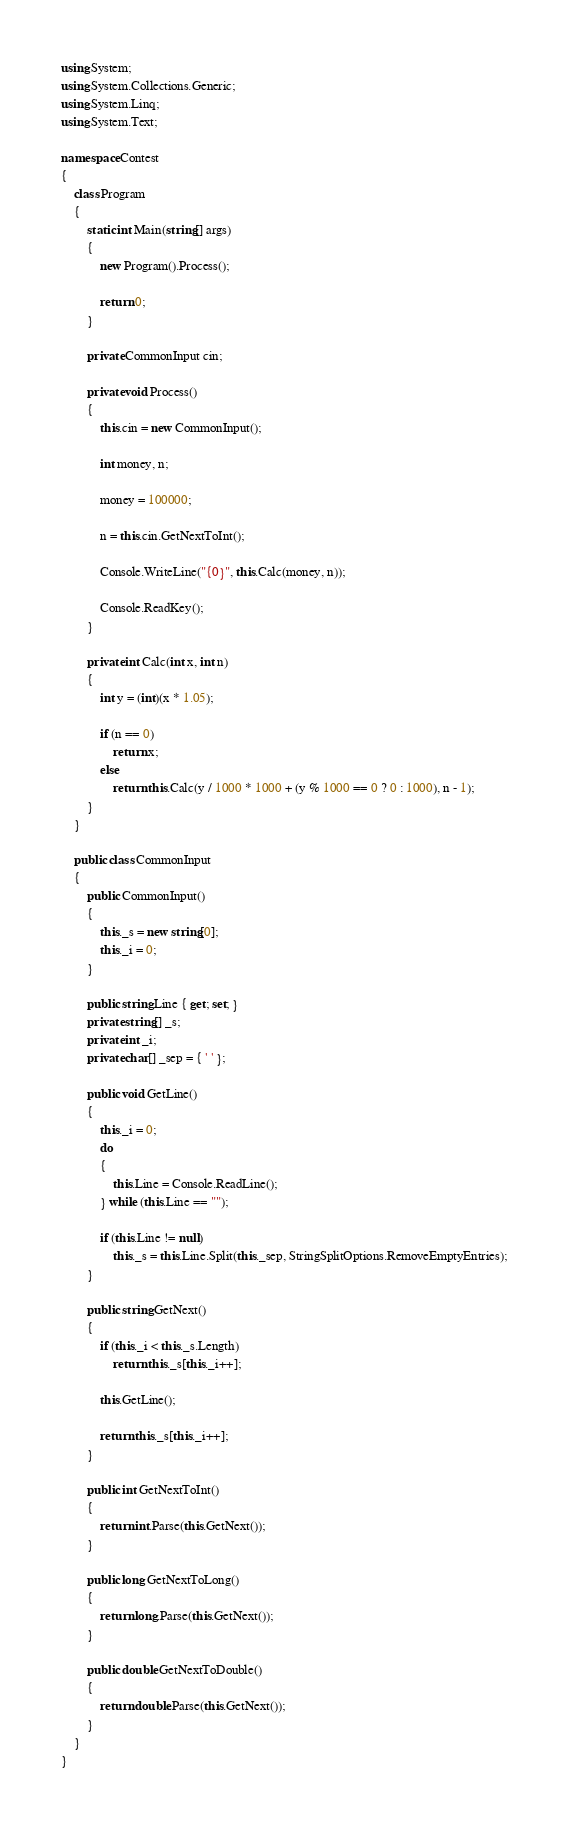<code> <loc_0><loc_0><loc_500><loc_500><_C#_>using System;
using System.Collections.Generic;
using System.Linq;
using System.Text;

namespace Contest
{
    class Program
    {
        static int Main(string[] args)
        {
            new Program().Process();

            return 0;
        }

        private CommonInput cin;

        private void Process()
        {
            this.cin = new CommonInput();

            int money, n;

            money = 100000;

            n = this.cin.GetNextToInt();

            Console.WriteLine("{0}", this.Calc(money, n));

            Console.ReadKey();
        }

        private int Calc(int x, int n)
        {
            int y = (int)(x * 1.05);

            if (n == 0)
                return x;
            else
                return this.Calc(y / 1000 * 1000 + (y % 1000 == 0 ? 0 : 1000), n - 1);
        }
    }

    public class CommonInput
    {
        public CommonInput()
        {
            this._s = new string[0];
            this._i = 0;
        }

        public string Line { get; set; }
        private string[] _s;
        private int _i;
        private char[] _sep = { ' ' };

        public void GetLine()
        {
            this._i = 0;
            do
            {
                this.Line = Console.ReadLine();
            } while (this.Line == "");

            if (this.Line != null)
                this._s = this.Line.Split(this._sep, StringSplitOptions.RemoveEmptyEntries);
        }

        public string GetNext()
        {
            if (this._i < this._s.Length)
                return this._s[this._i++];

            this.GetLine();

            return this._s[this._i++];
        }

        public int GetNextToInt()
        {
            return int.Parse(this.GetNext());
        }

        public long GetNextToLong()
        {
            return long.Parse(this.GetNext());
        }

        public double GetNextToDouble()
        {
            return double.Parse(this.GetNext());
        }
    }
}</code> 